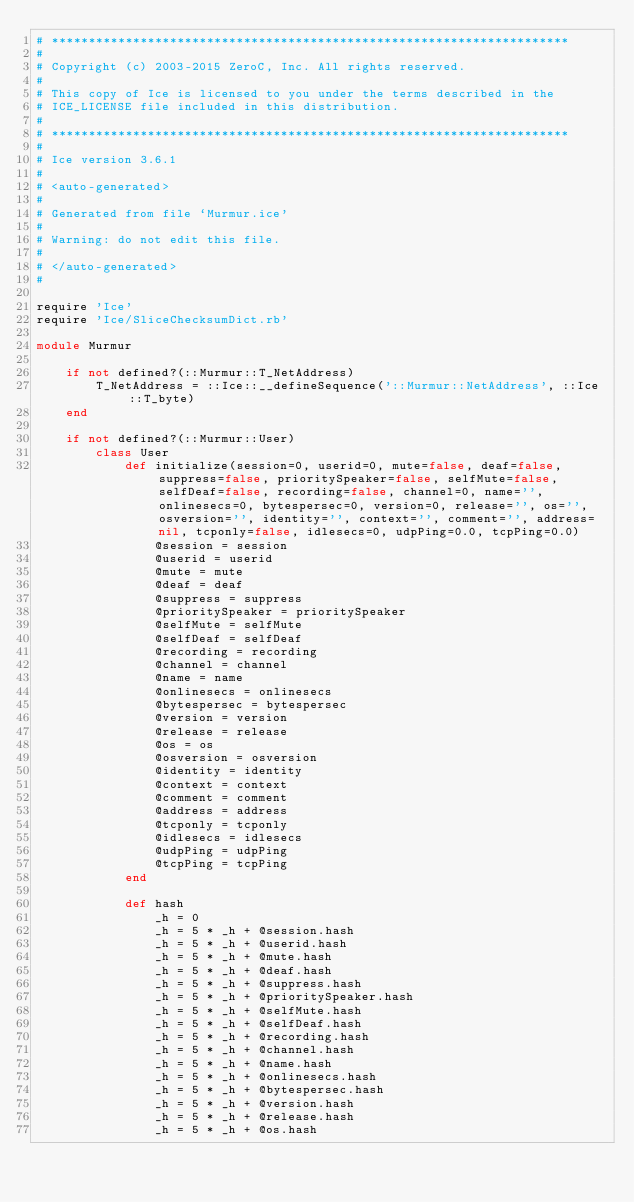<code> <loc_0><loc_0><loc_500><loc_500><_Ruby_># **********************************************************************
#
# Copyright (c) 2003-2015 ZeroC, Inc. All rights reserved.
#
# This copy of Ice is licensed to you under the terms described in the
# ICE_LICENSE file included in this distribution.
#
# **********************************************************************
#
# Ice version 3.6.1
#
# <auto-generated>
#
# Generated from file `Murmur.ice'
#
# Warning: do not edit this file.
#
# </auto-generated>
#

require 'Ice'
require 'Ice/SliceChecksumDict.rb'

module Murmur

    if not defined?(::Murmur::T_NetAddress)
        T_NetAddress = ::Ice::__defineSequence('::Murmur::NetAddress', ::Ice::T_byte)
    end

    if not defined?(::Murmur::User)
        class User
            def initialize(session=0, userid=0, mute=false, deaf=false, suppress=false, prioritySpeaker=false, selfMute=false, selfDeaf=false, recording=false, channel=0, name='', onlinesecs=0, bytespersec=0, version=0, release='', os='', osversion='', identity='', context='', comment='', address=nil, tcponly=false, idlesecs=0, udpPing=0.0, tcpPing=0.0)
                @session = session
                @userid = userid
                @mute = mute
                @deaf = deaf
                @suppress = suppress
                @prioritySpeaker = prioritySpeaker
                @selfMute = selfMute
                @selfDeaf = selfDeaf
                @recording = recording
                @channel = channel
                @name = name
                @onlinesecs = onlinesecs
                @bytespersec = bytespersec
                @version = version
                @release = release
                @os = os
                @osversion = osversion
                @identity = identity
                @context = context
                @comment = comment
                @address = address
                @tcponly = tcponly
                @idlesecs = idlesecs
                @udpPing = udpPing
                @tcpPing = tcpPing
            end

            def hash
                _h = 0
                _h = 5 * _h + @session.hash
                _h = 5 * _h + @userid.hash
                _h = 5 * _h + @mute.hash
                _h = 5 * _h + @deaf.hash
                _h = 5 * _h + @suppress.hash
                _h = 5 * _h + @prioritySpeaker.hash
                _h = 5 * _h + @selfMute.hash
                _h = 5 * _h + @selfDeaf.hash
                _h = 5 * _h + @recording.hash
                _h = 5 * _h + @channel.hash
                _h = 5 * _h + @name.hash
                _h = 5 * _h + @onlinesecs.hash
                _h = 5 * _h + @bytespersec.hash
                _h = 5 * _h + @version.hash
                _h = 5 * _h + @release.hash
                _h = 5 * _h + @os.hash</code> 